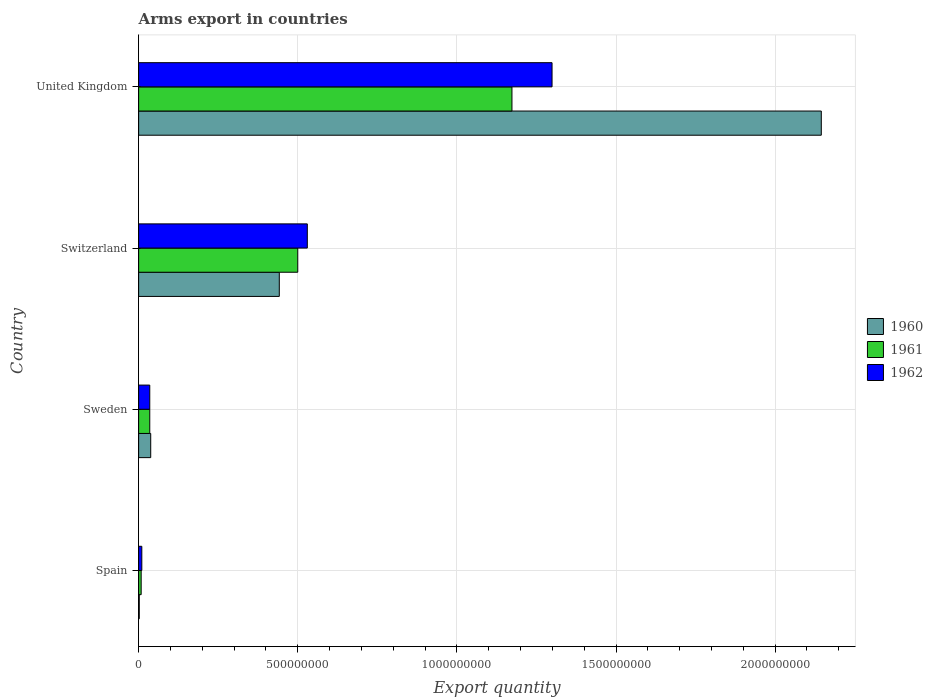In how many cases, is the number of bars for a given country not equal to the number of legend labels?
Your answer should be compact. 0. What is the total arms export in 1962 in Switzerland?
Make the answer very short. 5.30e+08. Across all countries, what is the maximum total arms export in 1961?
Your answer should be compact. 1.17e+09. What is the total total arms export in 1960 in the graph?
Provide a succinct answer. 2.63e+09. What is the difference between the total arms export in 1961 in Spain and that in United Kingdom?
Keep it short and to the point. -1.16e+09. What is the difference between the total arms export in 1962 in United Kingdom and the total arms export in 1961 in Switzerland?
Give a very brief answer. 7.99e+08. What is the average total arms export in 1962 per country?
Keep it short and to the point. 4.68e+08. In how many countries, is the total arms export in 1960 greater than 1200000000 ?
Provide a succinct answer. 1. What is the ratio of the total arms export in 1960 in Spain to that in United Kingdom?
Ensure brevity in your answer.  0. Is the difference between the total arms export in 1962 in Switzerland and United Kingdom greater than the difference between the total arms export in 1961 in Switzerland and United Kingdom?
Offer a terse response. No. What is the difference between the highest and the second highest total arms export in 1961?
Make the answer very short. 6.73e+08. What is the difference between the highest and the lowest total arms export in 1960?
Your answer should be very brief. 2.14e+09. In how many countries, is the total arms export in 1962 greater than the average total arms export in 1962 taken over all countries?
Keep it short and to the point. 2. Is the sum of the total arms export in 1960 in Switzerland and United Kingdom greater than the maximum total arms export in 1962 across all countries?
Provide a short and direct response. Yes. How many countries are there in the graph?
Ensure brevity in your answer.  4. Are the values on the major ticks of X-axis written in scientific E-notation?
Provide a short and direct response. No. Does the graph contain grids?
Ensure brevity in your answer.  Yes. Where does the legend appear in the graph?
Your answer should be compact. Center right. What is the title of the graph?
Provide a succinct answer. Arms export in countries. Does "1989" appear as one of the legend labels in the graph?
Offer a terse response. No. What is the label or title of the X-axis?
Offer a terse response. Export quantity. What is the label or title of the Y-axis?
Ensure brevity in your answer.  Country. What is the Export quantity of 1960 in Sweden?
Ensure brevity in your answer.  3.80e+07. What is the Export quantity of 1961 in Sweden?
Your answer should be compact. 3.50e+07. What is the Export quantity in 1962 in Sweden?
Offer a very short reply. 3.50e+07. What is the Export quantity of 1960 in Switzerland?
Your answer should be very brief. 4.42e+08. What is the Export quantity of 1961 in Switzerland?
Offer a terse response. 5.00e+08. What is the Export quantity in 1962 in Switzerland?
Ensure brevity in your answer.  5.30e+08. What is the Export quantity in 1960 in United Kingdom?
Provide a short and direct response. 2.14e+09. What is the Export quantity in 1961 in United Kingdom?
Offer a very short reply. 1.17e+09. What is the Export quantity in 1962 in United Kingdom?
Ensure brevity in your answer.  1.30e+09. Across all countries, what is the maximum Export quantity in 1960?
Your answer should be very brief. 2.14e+09. Across all countries, what is the maximum Export quantity in 1961?
Your answer should be compact. 1.17e+09. Across all countries, what is the maximum Export quantity of 1962?
Your answer should be very brief. 1.30e+09. Across all countries, what is the minimum Export quantity of 1961?
Ensure brevity in your answer.  8.00e+06. What is the total Export quantity in 1960 in the graph?
Your answer should be compact. 2.63e+09. What is the total Export quantity in 1961 in the graph?
Offer a very short reply. 1.72e+09. What is the total Export quantity in 1962 in the graph?
Keep it short and to the point. 1.87e+09. What is the difference between the Export quantity of 1960 in Spain and that in Sweden?
Ensure brevity in your answer.  -3.60e+07. What is the difference between the Export quantity of 1961 in Spain and that in Sweden?
Your answer should be compact. -2.70e+07. What is the difference between the Export quantity in 1962 in Spain and that in Sweden?
Your response must be concise. -2.50e+07. What is the difference between the Export quantity of 1960 in Spain and that in Switzerland?
Provide a succinct answer. -4.40e+08. What is the difference between the Export quantity in 1961 in Spain and that in Switzerland?
Offer a very short reply. -4.92e+08. What is the difference between the Export quantity of 1962 in Spain and that in Switzerland?
Offer a terse response. -5.20e+08. What is the difference between the Export quantity in 1960 in Spain and that in United Kingdom?
Your response must be concise. -2.14e+09. What is the difference between the Export quantity of 1961 in Spain and that in United Kingdom?
Your response must be concise. -1.16e+09. What is the difference between the Export quantity in 1962 in Spain and that in United Kingdom?
Make the answer very short. -1.29e+09. What is the difference between the Export quantity in 1960 in Sweden and that in Switzerland?
Your response must be concise. -4.04e+08. What is the difference between the Export quantity in 1961 in Sweden and that in Switzerland?
Make the answer very short. -4.65e+08. What is the difference between the Export quantity in 1962 in Sweden and that in Switzerland?
Give a very brief answer. -4.95e+08. What is the difference between the Export quantity of 1960 in Sweden and that in United Kingdom?
Give a very brief answer. -2.11e+09. What is the difference between the Export quantity of 1961 in Sweden and that in United Kingdom?
Your answer should be compact. -1.14e+09. What is the difference between the Export quantity in 1962 in Sweden and that in United Kingdom?
Ensure brevity in your answer.  -1.26e+09. What is the difference between the Export quantity in 1960 in Switzerland and that in United Kingdom?
Offer a very short reply. -1.70e+09. What is the difference between the Export quantity in 1961 in Switzerland and that in United Kingdom?
Provide a succinct answer. -6.73e+08. What is the difference between the Export quantity in 1962 in Switzerland and that in United Kingdom?
Make the answer very short. -7.69e+08. What is the difference between the Export quantity in 1960 in Spain and the Export quantity in 1961 in Sweden?
Keep it short and to the point. -3.30e+07. What is the difference between the Export quantity in 1960 in Spain and the Export quantity in 1962 in Sweden?
Offer a terse response. -3.30e+07. What is the difference between the Export quantity of 1961 in Spain and the Export quantity of 1962 in Sweden?
Your answer should be compact. -2.70e+07. What is the difference between the Export quantity of 1960 in Spain and the Export quantity of 1961 in Switzerland?
Offer a very short reply. -4.98e+08. What is the difference between the Export quantity in 1960 in Spain and the Export quantity in 1962 in Switzerland?
Provide a short and direct response. -5.28e+08. What is the difference between the Export quantity of 1961 in Spain and the Export quantity of 1962 in Switzerland?
Provide a succinct answer. -5.22e+08. What is the difference between the Export quantity in 1960 in Spain and the Export quantity in 1961 in United Kingdom?
Offer a very short reply. -1.17e+09. What is the difference between the Export quantity in 1960 in Spain and the Export quantity in 1962 in United Kingdom?
Give a very brief answer. -1.30e+09. What is the difference between the Export quantity of 1961 in Spain and the Export quantity of 1962 in United Kingdom?
Provide a short and direct response. -1.29e+09. What is the difference between the Export quantity in 1960 in Sweden and the Export quantity in 1961 in Switzerland?
Your answer should be very brief. -4.62e+08. What is the difference between the Export quantity in 1960 in Sweden and the Export quantity in 1962 in Switzerland?
Give a very brief answer. -4.92e+08. What is the difference between the Export quantity in 1961 in Sweden and the Export quantity in 1962 in Switzerland?
Offer a terse response. -4.95e+08. What is the difference between the Export quantity in 1960 in Sweden and the Export quantity in 1961 in United Kingdom?
Your response must be concise. -1.14e+09. What is the difference between the Export quantity of 1960 in Sweden and the Export quantity of 1962 in United Kingdom?
Provide a short and direct response. -1.26e+09. What is the difference between the Export quantity in 1961 in Sweden and the Export quantity in 1962 in United Kingdom?
Keep it short and to the point. -1.26e+09. What is the difference between the Export quantity of 1960 in Switzerland and the Export quantity of 1961 in United Kingdom?
Your answer should be very brief. -7.31e+08. What is the difference between the Export quantity in 1960 in Switzerland and the Export quantity in 1962 in United Kingdom?
Ensure brevity in your answer.  -8.57e+08. What is the difference between the Export quantity in 1961 in Switzerland and the Export quantity in 1962 in United Kingdom?
Your answer should be very brief. -7.99e+08. What is the average Export quantity of 1960 per country?
Your answer should be compact. 6.57e+08. What is the average Export quantity of 1961 per country?
Give a very brief answer. 4.29e+08. What is the average Export quantity in 1962 per country?
Provide a short and direct response. 4.68e+08. What is the difference between the Export quantity of 1960 and Export quantity of 1961 in Spain?
Ensure brevity in your answer.  -6.00e+06. What is the difference between the Export quantity in 1960 and Export quantity in 1962 in Spain?
Your answer should be very brief. -8.00e+06. What is the difference between the Export quantity of 1961 and Export quantity of 1962 in Spain?
Offer a very short reply. -2.00e+06. What is the difference between the Export quantity in 1960 and Export quantity in 1961 in Sweden?
Your response must be concise. 3.00e+06. What is the difference between the Export quantity in 1961 and Export quantity in 1962 in Sweden?
Your response must be concise. 0. What is the difference between the Export quantity in 1960 and Export quantity in 1961 in Switzerland?
Keep it short and to the point. -5.80e+07. What is the difference between the Export quantity of 1960 and Export quantity of 1962 in Switzerland?
Offer a terse response. -8.80e+07. What is the difference between the Export quantity in 1961 and Export quantity in 1962 in Switzerland?
Your response must be concise. -3.00e+07. What is the difference between the Export quantity in 1960 and Export quantity in 1961 in United Kingdom?
Offer a very short reply. 9.72e+08. What is the difference between the Export quantity in 1960 and Export quantity in 1962 in United Kingdom?
Provide a succinct answer. 8.46e+08. What is the difference between the Export quantity of 1961 and Export quantity of 1962 in United Kingdom?
Provide a short and direct response. -1.26e+08. What is the ratio of the Export quantity in 1960 in Spain to that in Sweden?
Ensure brevity in your answer.  0.05. What is the ratio of the Export quantity of 1961 in Spain to that in Sweden?
Ensure brevity in your answer.  0.23. What is the ratio of the Export quantity of 1962 in Spain to that in Sweden?
Give a very brief answer. 0.29. What is the ratio of the Export quantity of 1960 in Spain to that in Switzerland?
Offer a very short reply. 0. What is the ratio of the Export quantity in 1961 in Spain to that in Switzerland?
Keep it short and to the point. 0.02. What is the ratio of the Export quantity of 1962 in Spain to that in Switzerland?
Offer a terse response. 0.02. What is the ratio of the Export quantity in 1960 in Spain to that in United Kingdom?
Provide a short and direct response. 0. What is the ratio of the Export quantity in 1961 in Spain to that in United Kingdom?
Give a very brief answer. 0.01. What is the ratio of the Export quantity in 1962 in Spain to that in United Kingdom?
Offer a terse response. 0.01. What is the ratio of the Export quantity in 1960 in Sweden to that in Switzerland?
Your answer should be very brief. 0.09. What is the ratio of the Export quantity of 1961 in Sweden to that in Switzerland?
Your response must be concise. 0.07. What is the ratio of the Export quantity of 1962 in Sweden to that in Switzerland?
Provide a succinct answer. 0.07. What is the ratio of the Export quantity in 1960 in Sweden to that in United Kingdom?
Provide a short and direct response. 0.02. What is the ratio of the Export quantity in 1961 in Sweden to that in United Kingdom?
Your answer should be very brief. 0.03. What is the ratio of the Export quantity of 1962 in Sweden to that in United Kingdom?
Provide a short and direct response. 0.03. What is the ratio of the Export quantity of 1960 in Switzerland to that in United Kingdom?
Provide a short and direct response. 0.21. What is the ratio of the Export quantity of 1961 in Switzerland to that in United Kingdom?
Ensure brevity in your answer.  0.43. What is the ratio of the Export quantity in 1962 in Switzerland to that in United Kingdom?
Your response must be concise. 0.41. What is the difference between the highest and the second highest Export quantity of 1960?
Offer a terse response. 1.70e+09. What is the difference between the highest and the second highest Export quantity of 1961?
Give a very brief answer. 6.73e+08. What is the difference between the highest and the second highest Export quantity in 1962?
Offer a terse response. 7.69e+08. What is the difference between the highest and the lowest Export quantity of 1960?
Provide a succinct answer. 2.14e+09. What is the difference between the highest and the lowest Export quantity of 1961?
Offer a very short reply. 1.16e+09. What is the difference between the highest and the lowest Export quantity in 1962?
Your answer should be compact. 1.29e+09. 